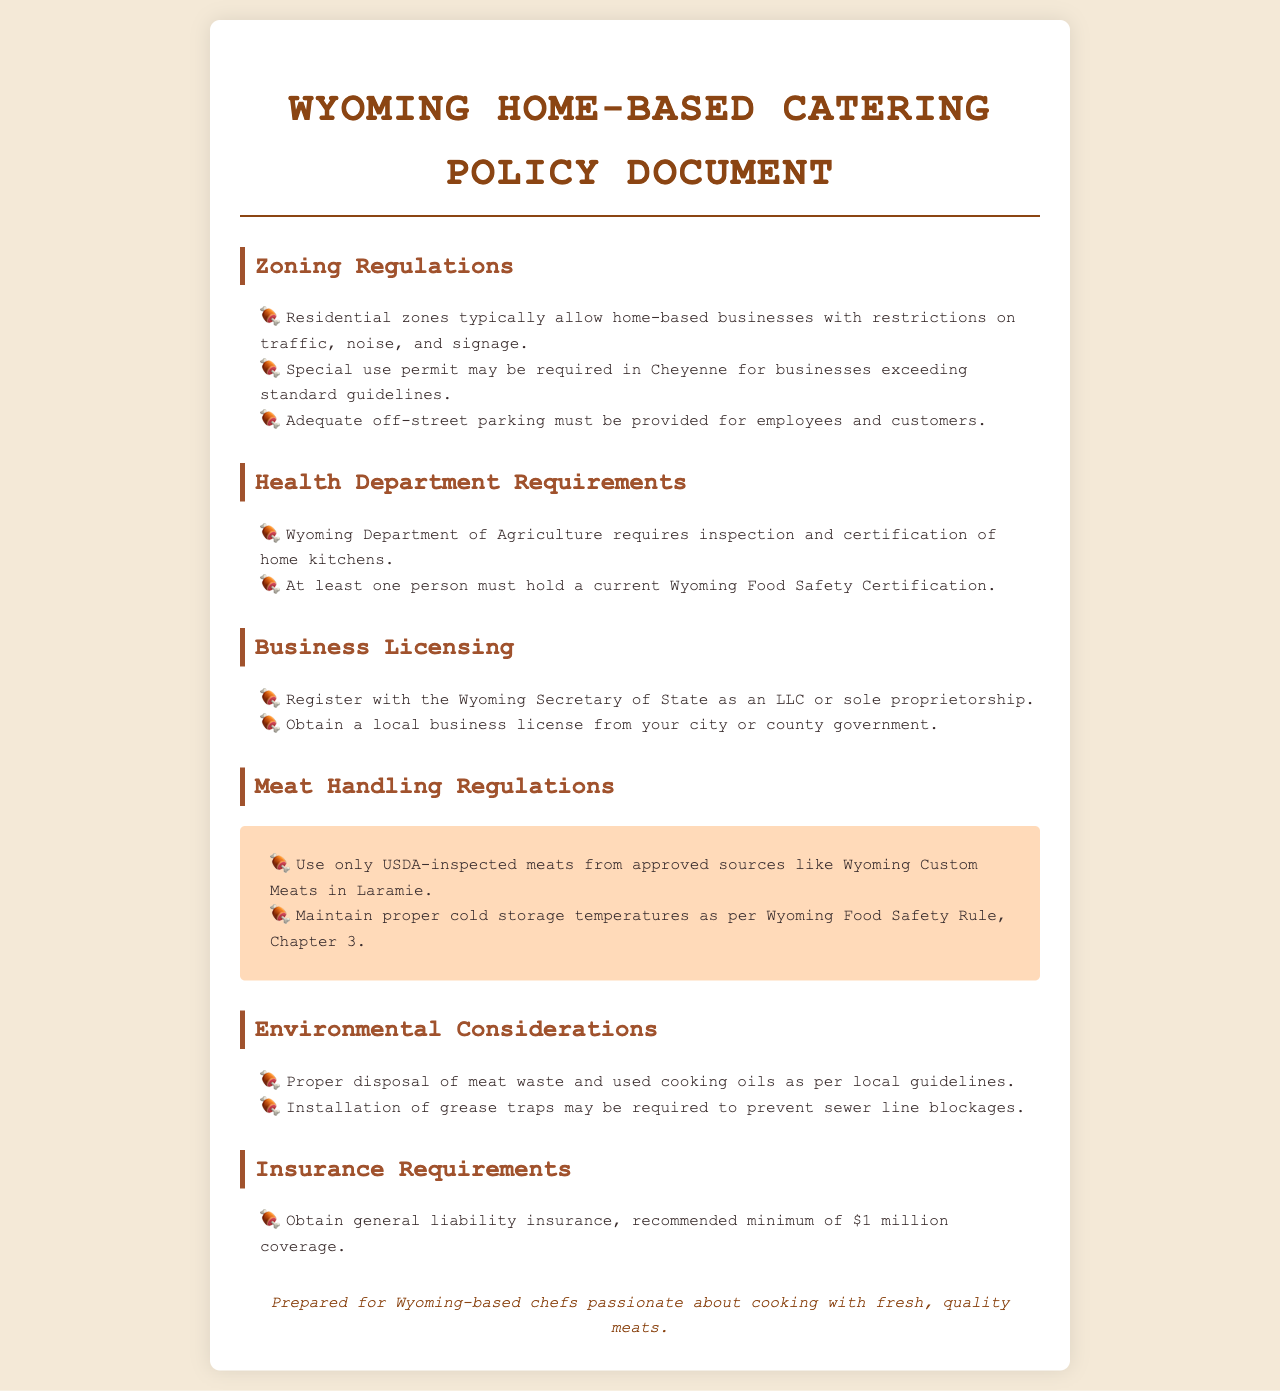What type of permit may be required in Cheyenne? The document states that a special use permit may be required in Cheyenne for businesses exceeding standard guidelines.
Answer: special use permit What certification is required for at least one person in the business? The document mentions that at least one person must hold a current Wyoming Food Safety Certification.
Answer: Wyoming Food Safety Certification What is the recommended minimum coverage for general liability insurance? The document highlights that the recommended minimum coverage for general liability insurance is $1 million.
Answer: $1 million What types of zones typically allow home-based businesses? The document specifies that residential zones typically allow home-based businesses.
Answer: residential zones Which agency requires inspection and certification of home kitchens? The document indicates that the Wyoming Department of Agriculture requires inspection and certification of home kitchens.
Answer: Wyoming Department of Agriculture What must be maintained according to Wyoming Food Safety Rule, Chapter 3? The document states that proper cold storage temperatures must be maintained as per Wyoming Food Safety Rule, Chapter 3.
Answer: proper cold storage temperatures What is a common environmental consideration mentioned in the document? The document mentions proper disposal of meat waste and used cooking oils as a common environmental consideration.
Answer: proper disposal of meat waste and used cooking oils Which meats must be used according to the document? The document specifies that only USDA-inspected meats from approved sources must be used.
Answer: USDA-inspected meats from approved sources 